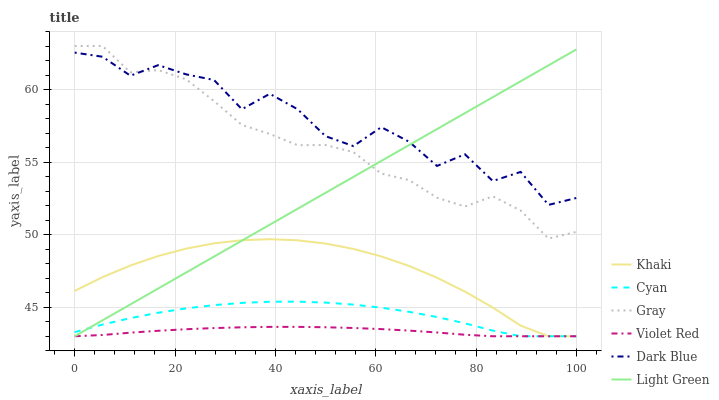Does Violet Red have the minimum area under the curve?
Answer yes or no. Yes. Does Dark Blue have the maximum area under the curve?
Answer yes or no. Yes. Does Khaki have the minimum area under the curve?
Answer yes or no. No. Does Khaki have the maximum area under the curve?
Answer yes or no. No. Is Light Green the smoothest?
Answer yes or no. Yes. Is Dark Blue the roughest?
Answer yes or no. Yes. Is Violet Red the smoothest?
Answer yes or no. No. Is Violet Red the roughest?
Answer yes or no. No. Does Violet Red have the lowest value?
Answer yes or no. Yes. Does Dark Blue have the lowest value?
Answer yes or no. No. Does Gray have the highest value?
Answer yes or no. Yes. Does Khaki have the highest value?
Answer yes or no. No. Is Khaki less than Gray?
Answer yes or no. Yes. Is Gray greater than Violet Red?
Answer yes or no. Yes. Does Khaki intersect Violet Red?
Answer yes or no. Yes. Is Khaki less than Violet Red?
Answer yes or no. No. Is Khaki greater than Violet Red?
Answer yes or no. No. Does Khaki intersect Gray?
Answer yes or no. No. 